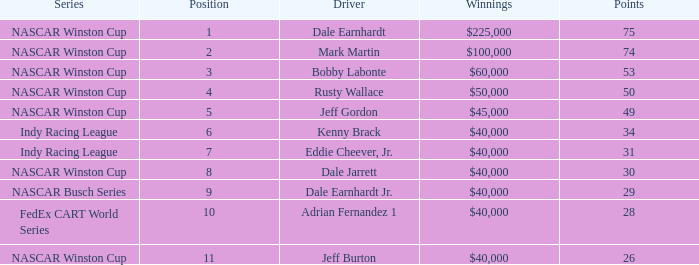What position did the driver earn 31 points? 7.0. 